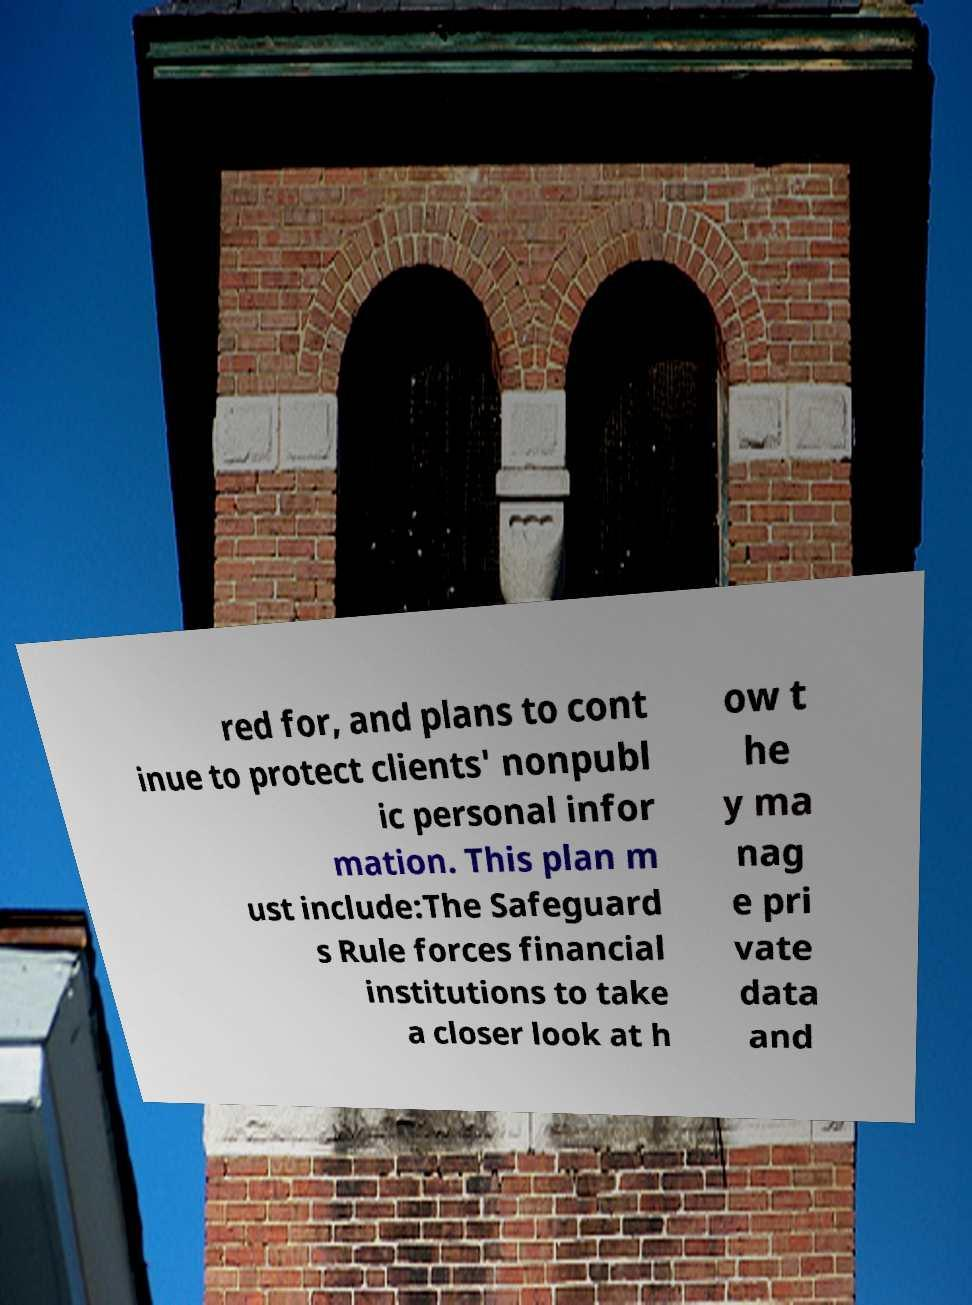Please identify and transcribe the text found in this image. red for, and plans to cont inue to protect clients' nonpubl ic personal infor mation. This plan m ust include:The Safeguard s Rule forces financial institutions to take a closer look at h ow t he y ma nag e pri vate data and 